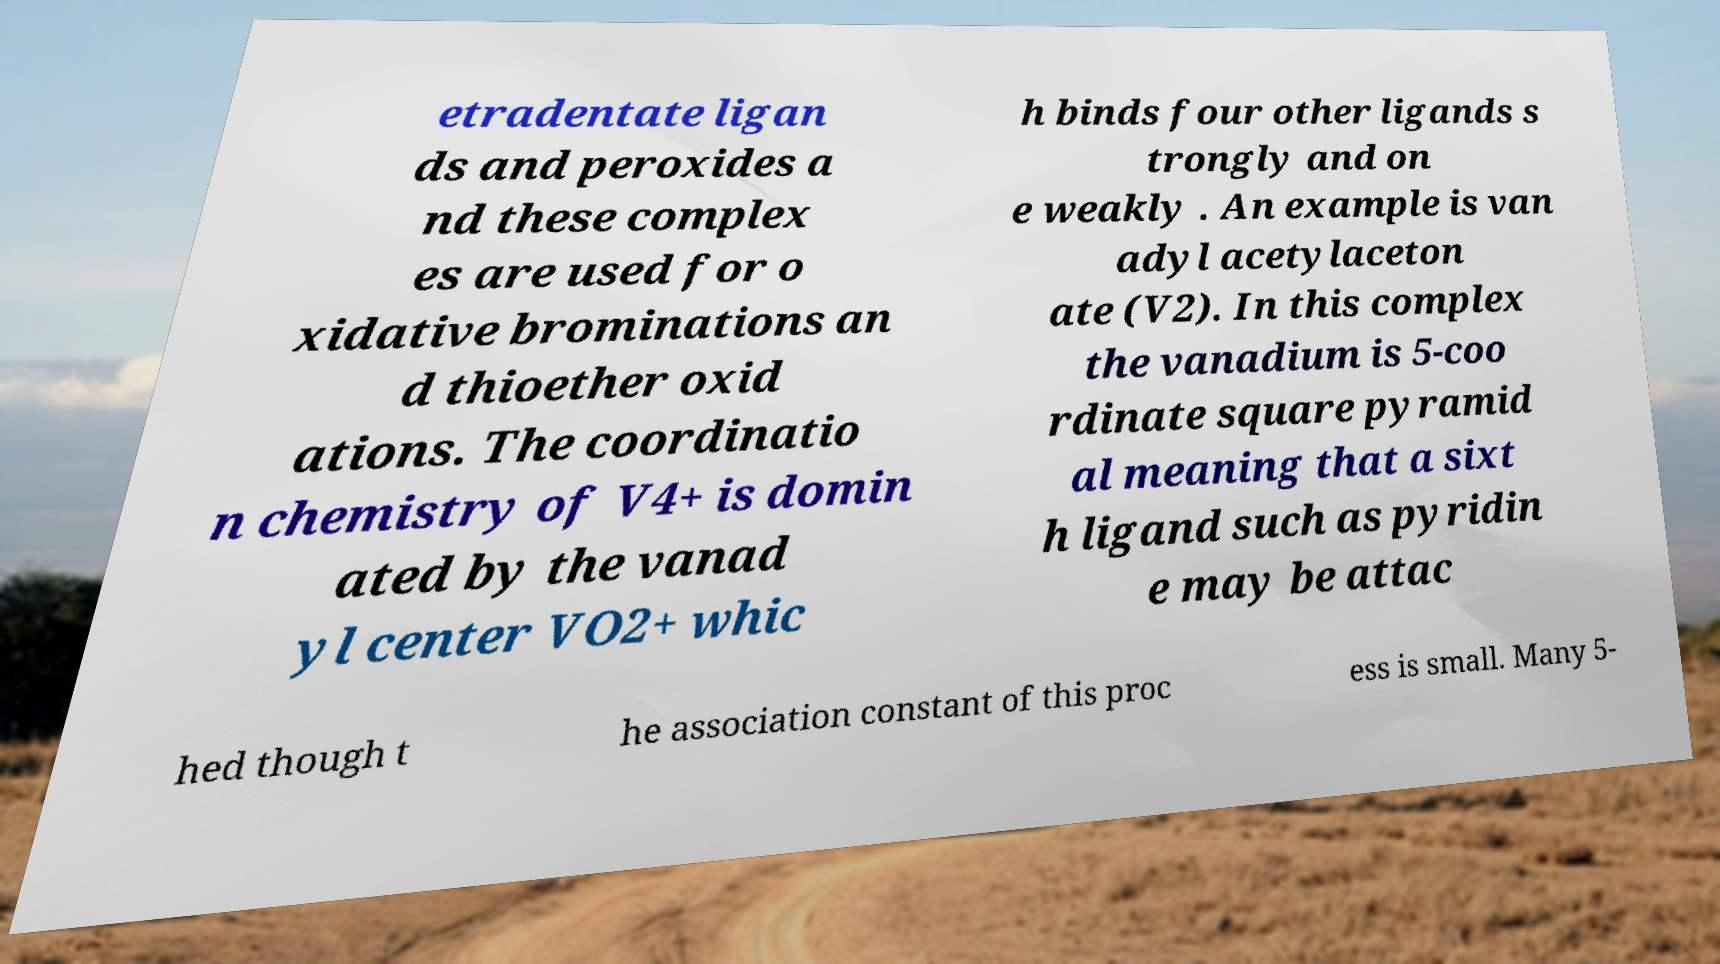Could you assist in decoding the text presented in this image and type it out clearly? etradentate ligan ds and peroxides a nd these complex es are used for o xidative brominations an d thioether oxid ations. The coordinatio n chemistry of V4+ is domin ated by the vanad yl center VO2+ whic h binds four other ligands s trongly and on e weakly . An example is van adyl acetylaceton ate (V2). In this complex the vanadium is 5-coo rdinate square pyramid al meaning that a sixt h ligand such as pyridin e may be attac hed though t he association constant of this proc ess is small. Many 5- 